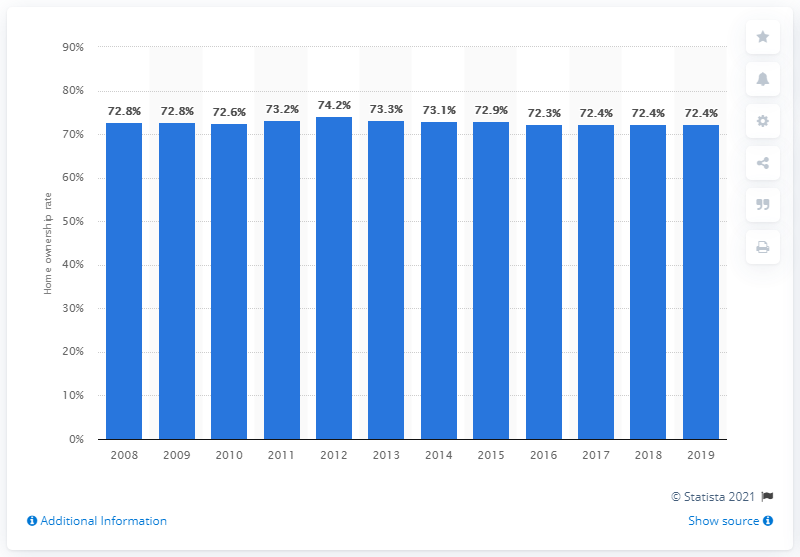Mention a couple of crucial points in this snapshot. The home ownership rate in Italy is 72.4%. 